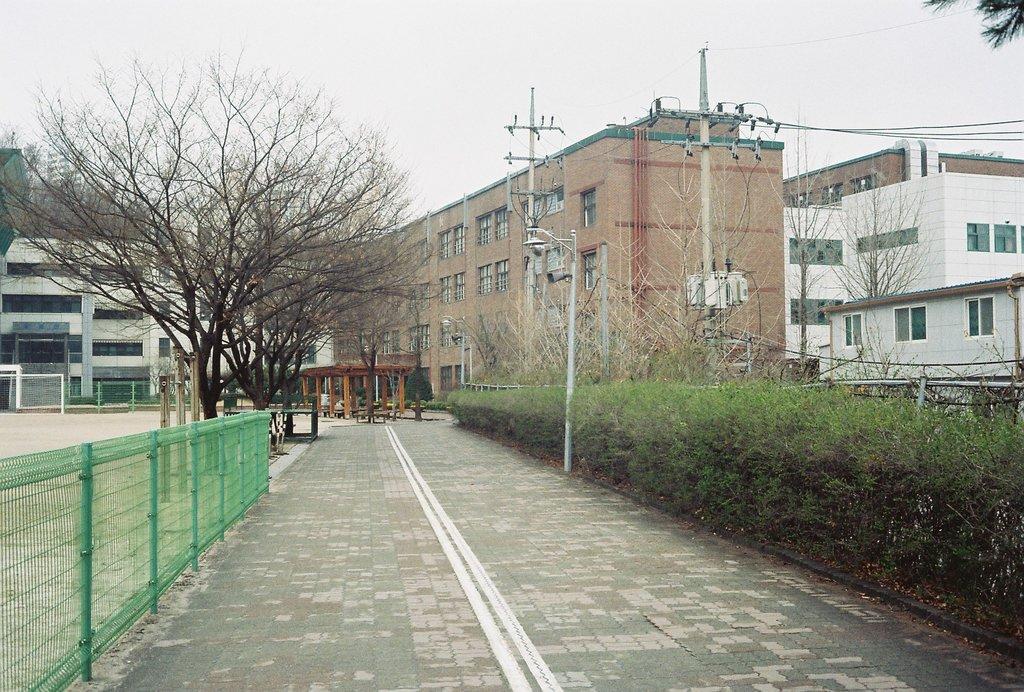Can you describe this image briefly? In this image we can see a road. On the right side of the image, we can see plants, poles, wires and buildings. On the left side of the image, we can see fence, pavement, trees and buildings. We can see the sky at the top of the image. 